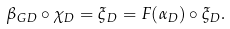Convert formula to latex. <formula><loc_0><loc_0><loc_500><loc_500>\beta _ { G D } \circ \chi _ { D } = \xi _ { D } = F ( \alpha _ { D } ) \circ \xi _ { D } .</formula> 